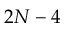<formula> <loc_0><loc_0><loc_500><loc_500>2 N - 4</formula> 